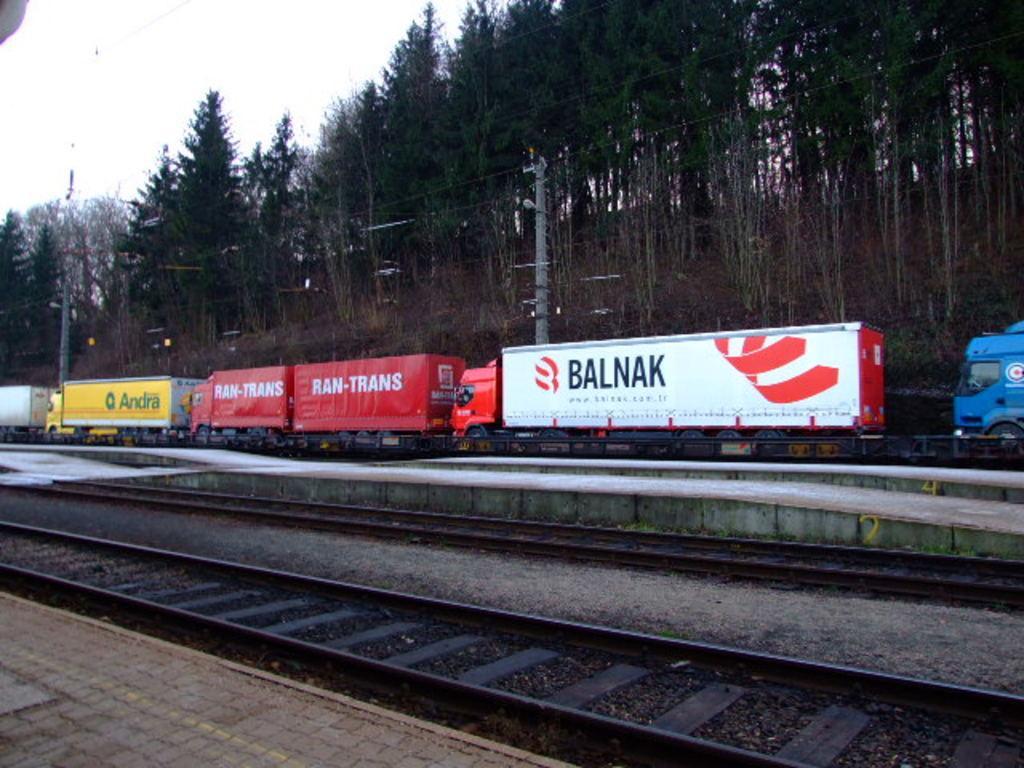Can you describe this image briefly? In this picture we can see there are railway tracks. Behind the railway tracks there are vehicles, trees and electric poles with cables. Behind the trees there is the sky. 